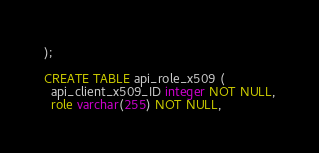Convert code to text. <code><loc_0><loc_0><loc_500><loc_500><_SQL_>);

CREATE TABLE api_role_x509 (
  api_client_x509_ID integer NOT NULL,
  role varchar(255) NOT NULL,</code> 